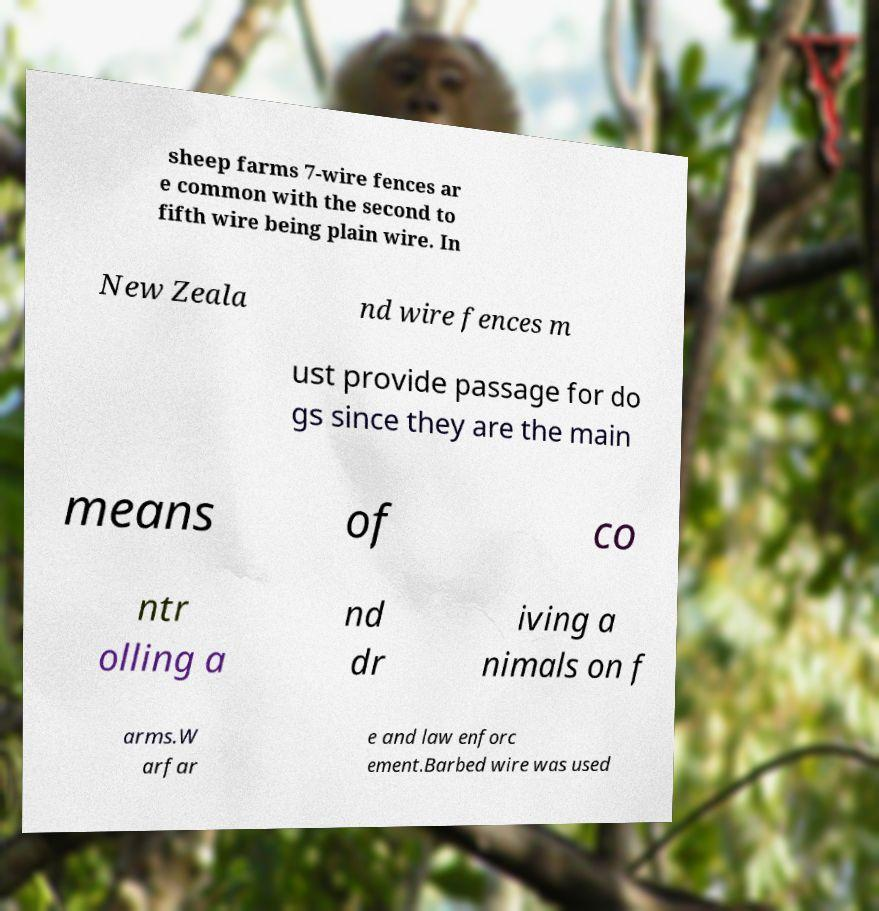Could you extract and type out the text from this image? sheep farms 7-wire fences ar e common with the second to fifth wire being plain wire. In New Zeala nd wire fences m ust provide passage for do gs since they are the main means of co ntr olling a nd dr iving a nimals on f arms.W arfar e and law enforc ement.Barbed wire was used 